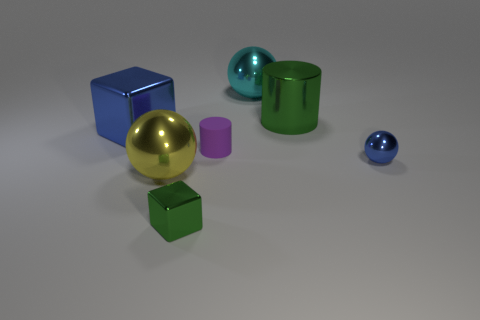Add 3 big yellow shiny objects. How many objects exist? 10 Subtract all cylinders. How many objects are left? 5 Add 5 large shiny cylinders. How many large shiny cylinders are left? 6 Add 2 tiny cyan metallic balls. How many tiny cyan metallic balls exist? 2 Subtract 0 brown cylinders. How many objects are left? 7 Subtract all small rubber objects. Subtract all large metallic cubes. How many objects are left? 5 